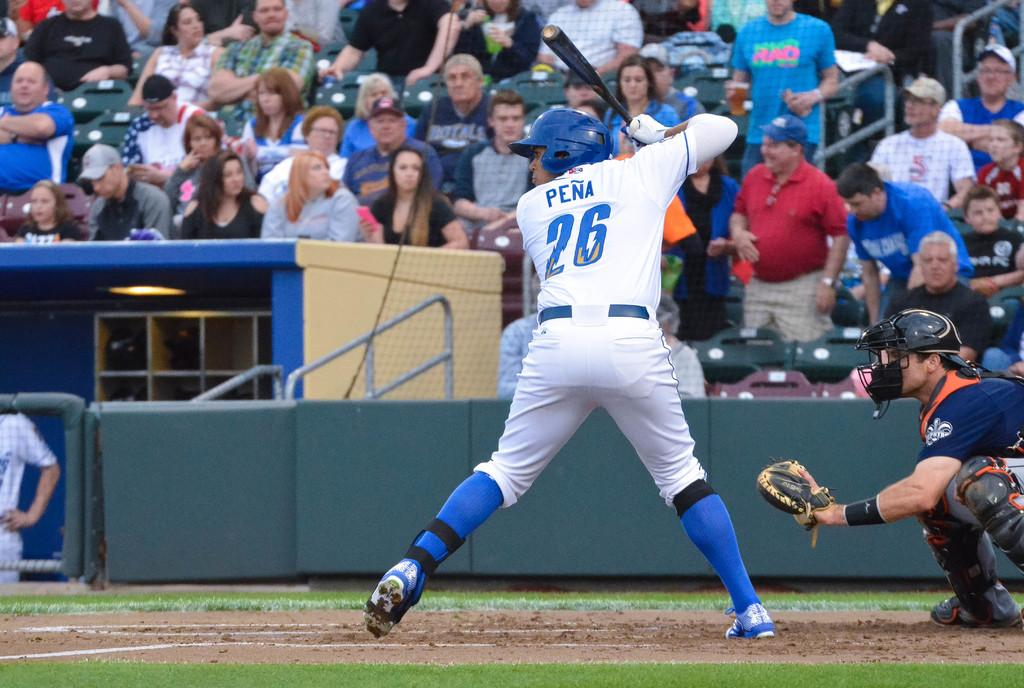<image>
Give a short and clear explanation of the subsequent image. The number 26 is on the back of a baseball players jersey. 